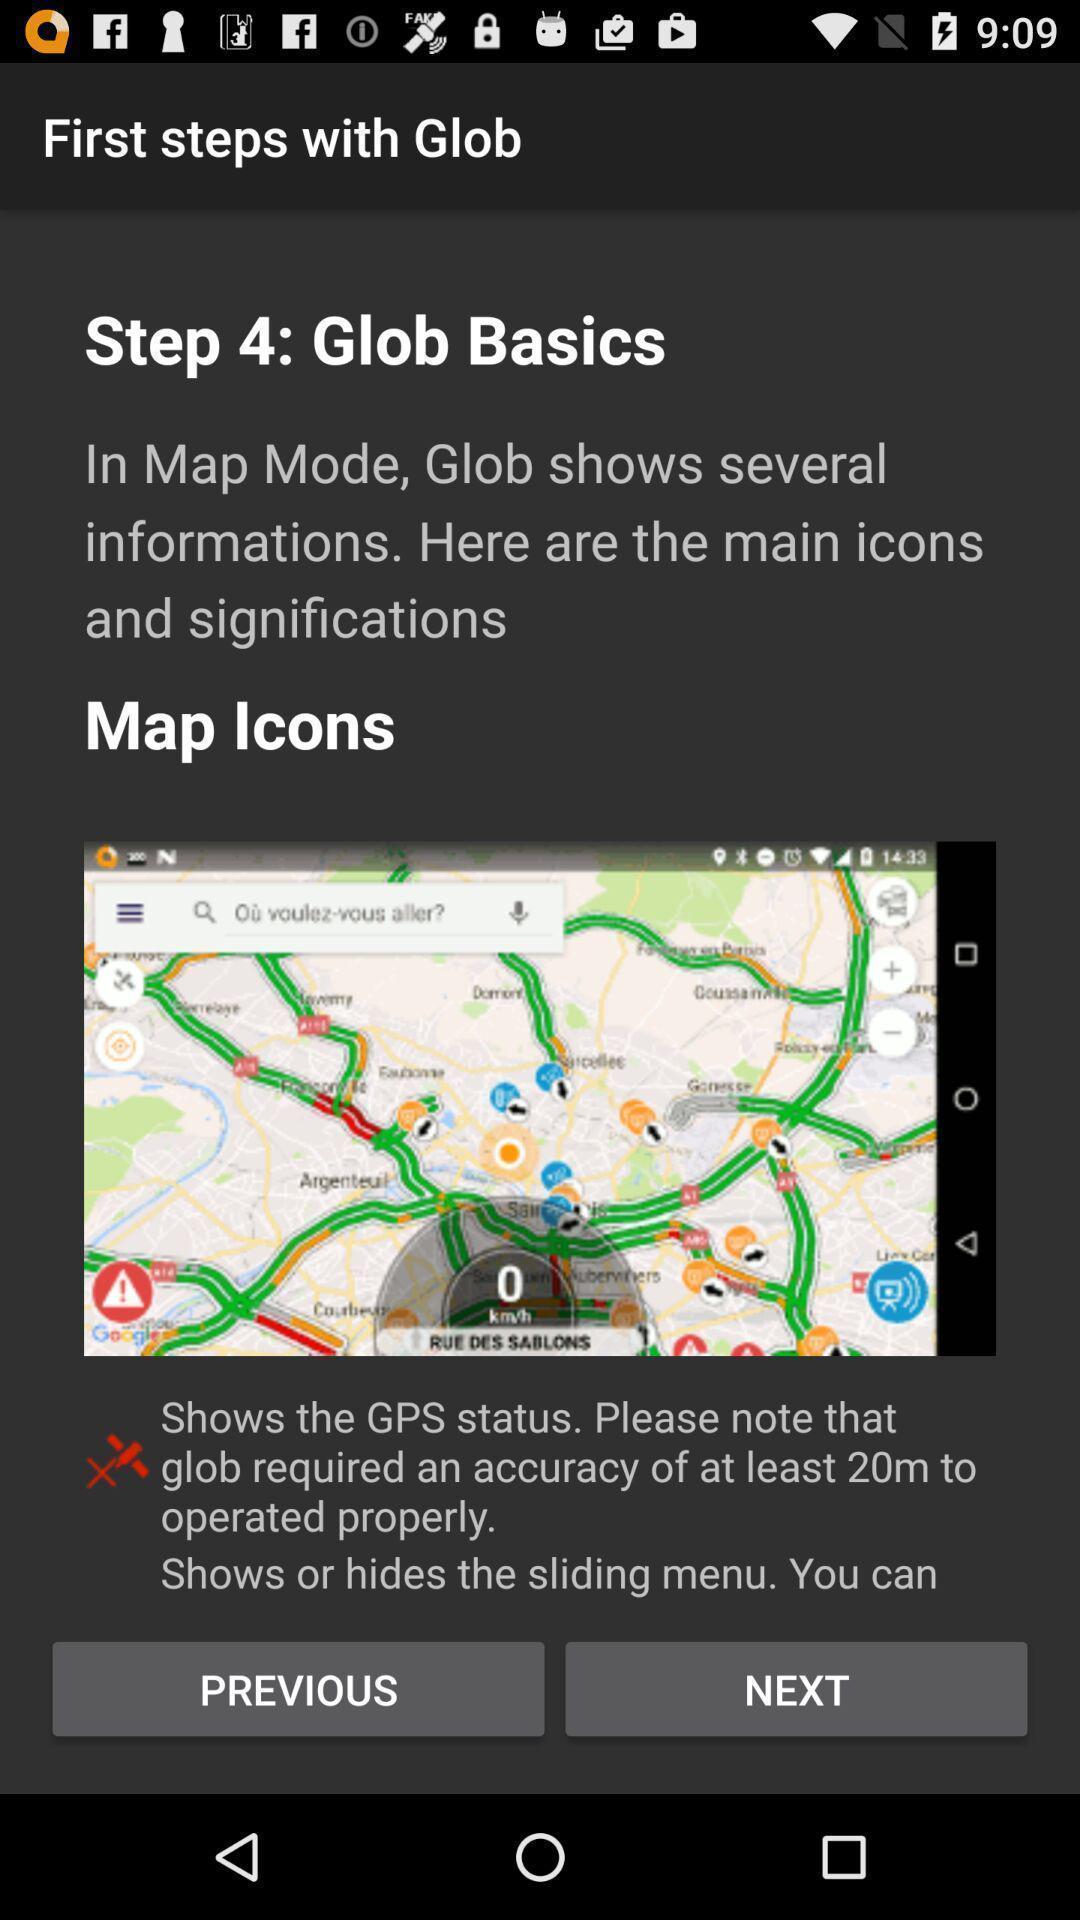Describe the content in this image. Screen displaying the steps page of gps based app. 